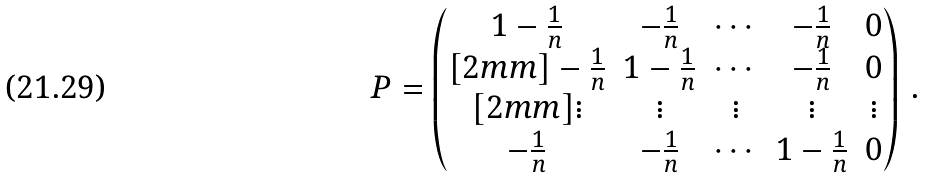Convert formula to latex. <formula><loc_0><loc_0><loc_500><loc_500>P = \begin{pmatrix} 1 - \frac { 1 } { n } & - \frac { 1 } { n } & \cdots & - \frac { 1 } { n } & 0 \\ [ 2 m m ] - \frac { 1 } { n } & 1 - \frac { 1 } { n } & \cdots & - \frac { 1 } { n } & 0 \\ [ 2 m m ] \vdots & \vdots & \vdots & \vdots & \vdots \\ - \frac { 1 } { n } & - \frac { 1 } { n } & \cdots & 1 - \frac { 1 } { n } & 0 \end{pmatrix} \, .</formula> 